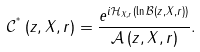Convert formula to latex. <formula><loc_0><loc_0><loc_500><loc_500>\mathcal { C } ^ { ^ { * } } \left ( z , X , r \right ) = \frac { e ^ { i \mathcal { H } _ { X , r } \left ( \ln \mathcal { B } \left ( z , X , r \right ) \right ) } } { \mathcal { A } \left ( z , X , r \right ) } .</formula> 